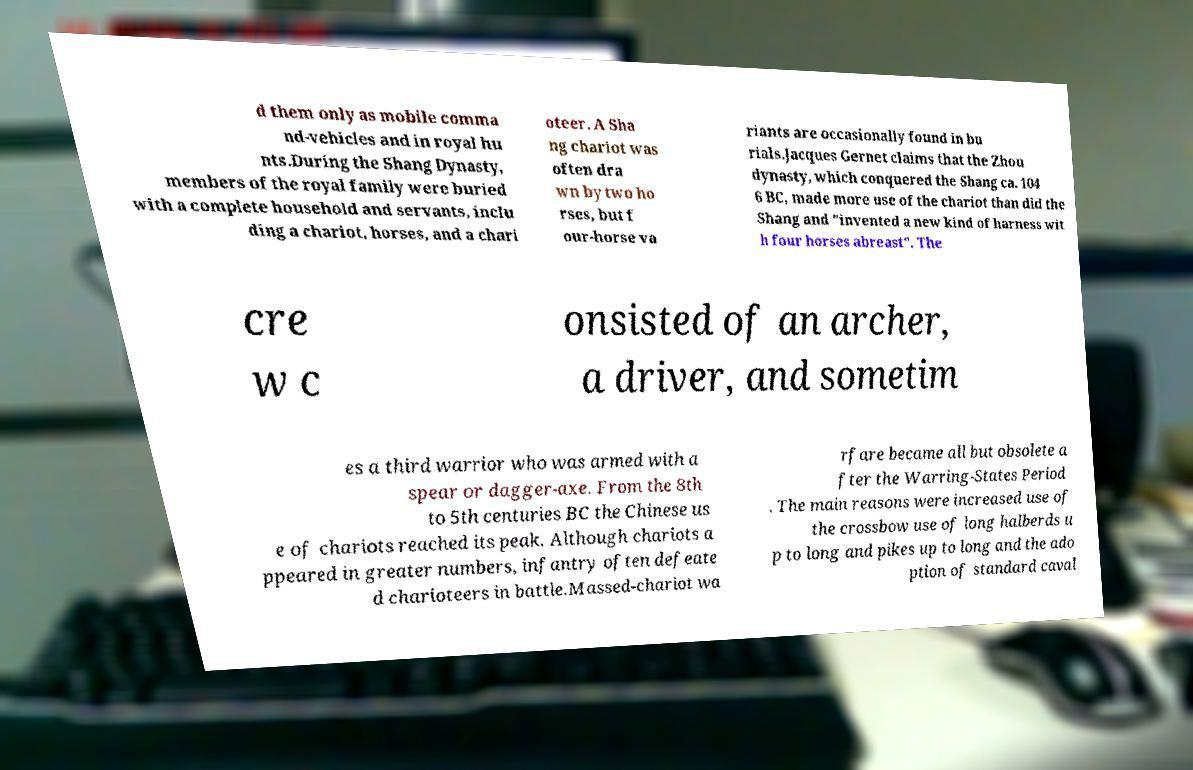Please identify and transcribe the text found in this image. d them only as mobile comma nd-vehicles and in royal hu nts.During the Shang Dynasty, members of the royal family were buried with a complete household and servants, inclu ding a chariot, horses, and a chari oteer. A Sha ng chariot was often dra wn by two ho rses, but f our-horse va riants are occasionally found in bu rials.Jacques Gernet claims that the Zhou dynasty, which conquered the Shang ca. 104 6 BC, made more use of the chariot than did the Shang and "invented a new kind of harness wit h four horses abreast". The cre w c onsisted of an archer, a driver, and sometim es a third warrior who was armed with a spear or dagger-axe. From the 8th to 5th centuries BC the Chinese us e of chariots reached its peak. Although chariots a ppeared in greater numbers, infantry often defeate d charioteers in battle.Massed-chariot wa rfare became all but obsolete a fter the Warring-States Period . The main reasons were increased use of the crossbow use of long halberds u p to long and pikes up to long and the ado ption of standard caval 